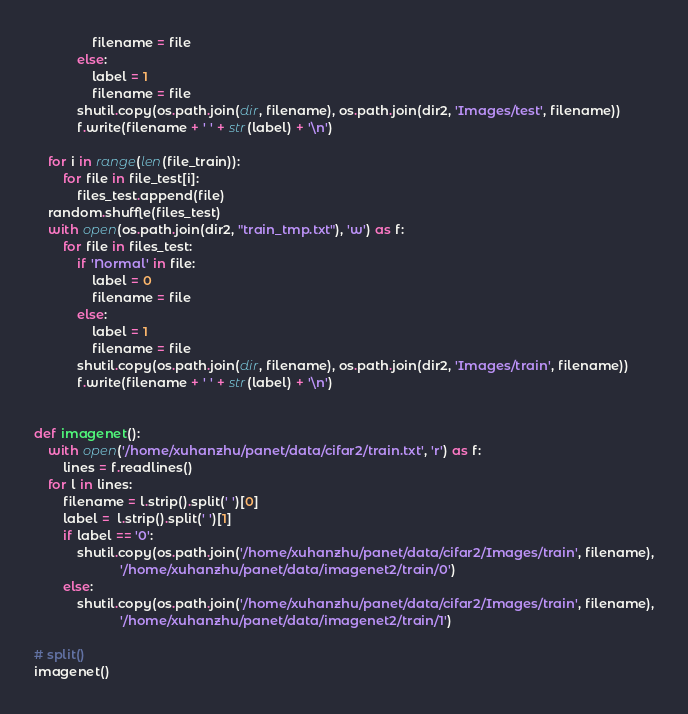Convert code to text. <code><loc_0><loc_0><loc_500><loc_500><_Python_>                filename = file
            else:
                label = 1
                filename = file
            shutil.copy(os.path.join(dir, filename), os.path.join(dir2, 'Images/test', filename))
            f.write(filename + ' ' + str(label) + '\n')

    for i in range(len(file_train)):
        for file in file_test[i]:
            files_test.append(file)
    random.shuffle(files_test)
    with open(os.path.join(dir2, "train_tmp.txt"), 'w') as f:
        for file in files_test:
            if 'Normal' in file:
                label = 0
                filename = file
            else:
                label = 1
                filename = file
            shutil.copy(os.path.join(dir, filename), os.path.join(dir2, 'Images/train', filename))
            f.write(filename + ' ' + str(label) + '\n')


def imagenet():
    with open('/home/xuhanzhu/panet/data/cifar2/train.txt', 'r') as f:
        lines = f.readlines()
    for l in lines:
        filename = l.strip().split(' ')[0]
        label =  l.strip().split(' ')[1]
        if label == '0':
            shutil.copy(os.path.join('/home/xuhanzhu/panet/data/cifar2/Images/train', filename),
                        '/home/xuhanzhu/panet/data/imagenet2/train/0')
        else:
            shutil.copy(os.path.join('/home/xuhanzhu/panet/data/cifar2/Images/train', filename),
                        '/home/xuhanzhu/panet/data/imagenet2/train/1')

# split()
imagenet()
</code> 